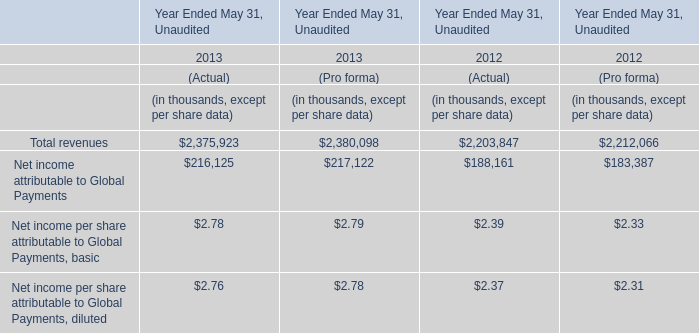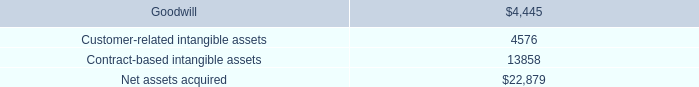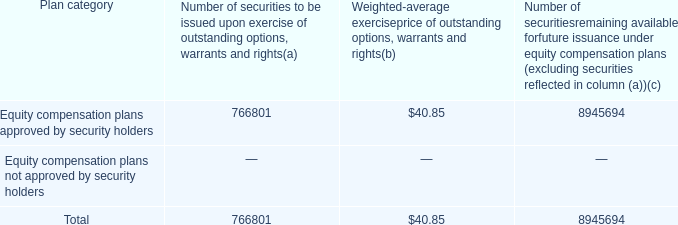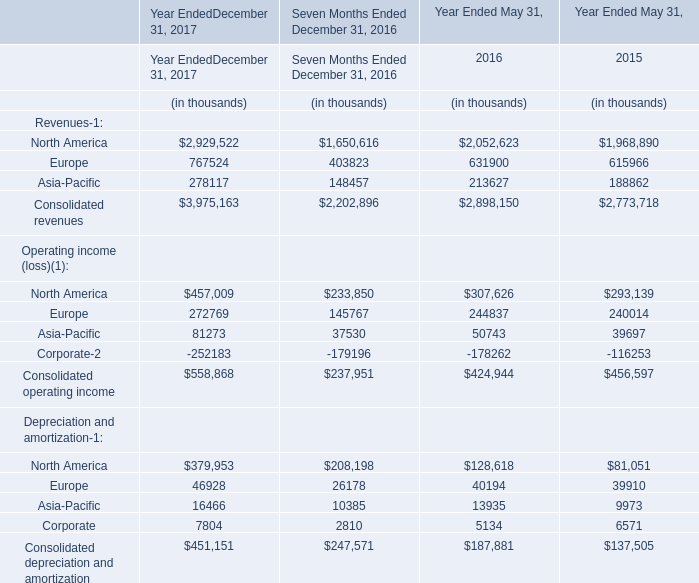what is the total value of securities approved by security holders but net yer issued , ( in millions ) ? 
Computations: ((8945694 * 40.85) / 1000000)
Answer: 365.4316. 